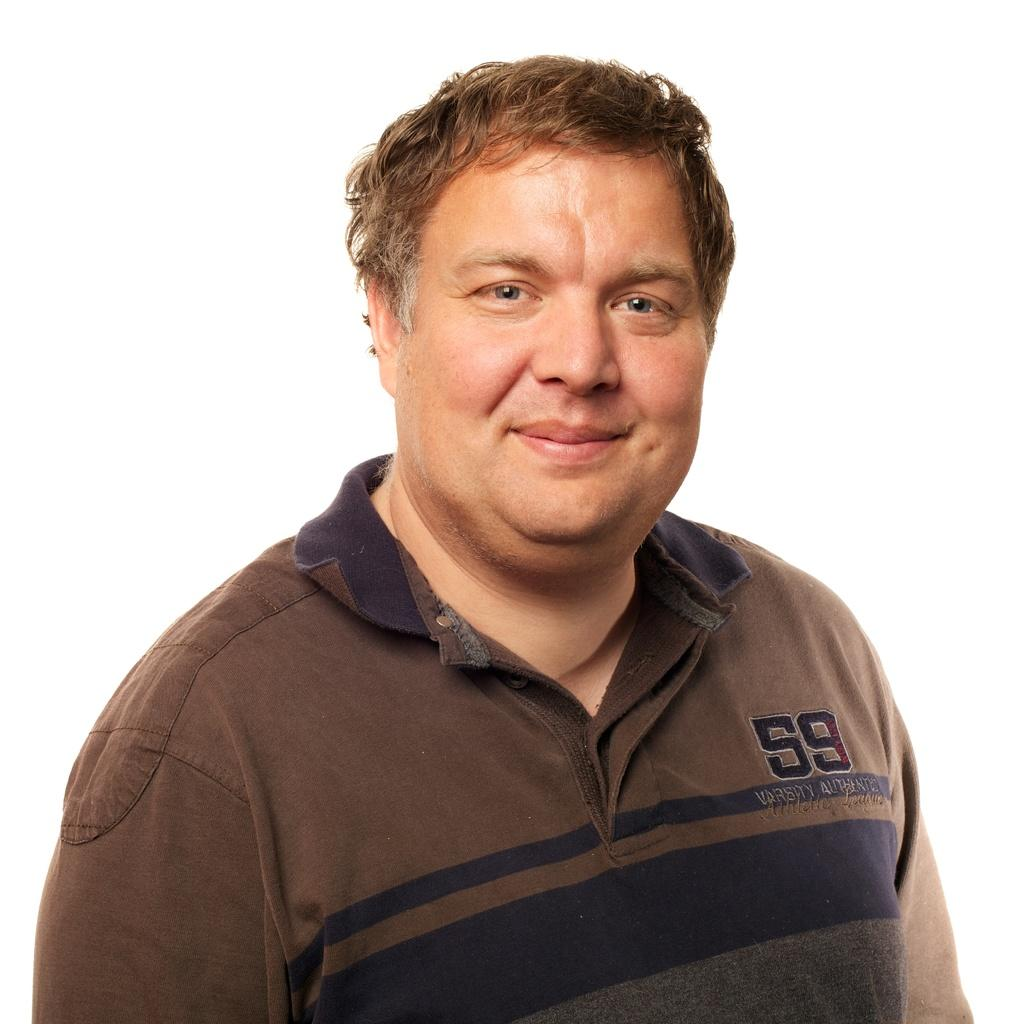What is the main subject of the image? The main subject of the image is a man. What is the man wearing in the image? The man is wearing a brown T-shirt in the image. What is the man's facial expression in the image? The man is smiling in the image. What color is the background of the image? The background of the image is white in color. What type of game is the man playing in the image? There is no game present in the image; it only features a man wearing a brown T-shirt and smiling. Can you tell me how many arrows are in the man's quiver in the image? There is no quiver or arrows present in the image. 